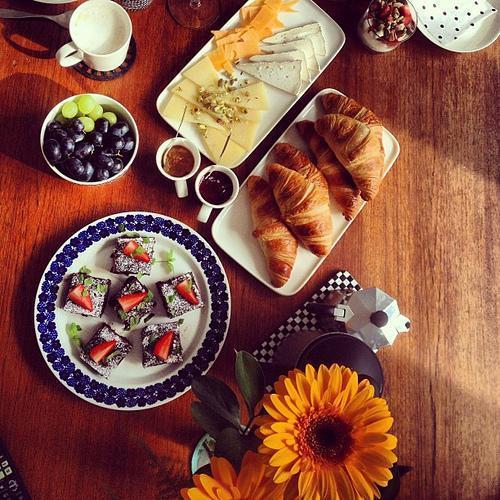How many flowers are there?
Give a very brief answer. 2. How many mugs are there?
Give a very brief answer. 1. 